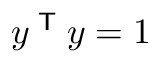<formula> <loc_0><loc_0><loc_500><loc_500>y ^ { T } y = 1</formula> 